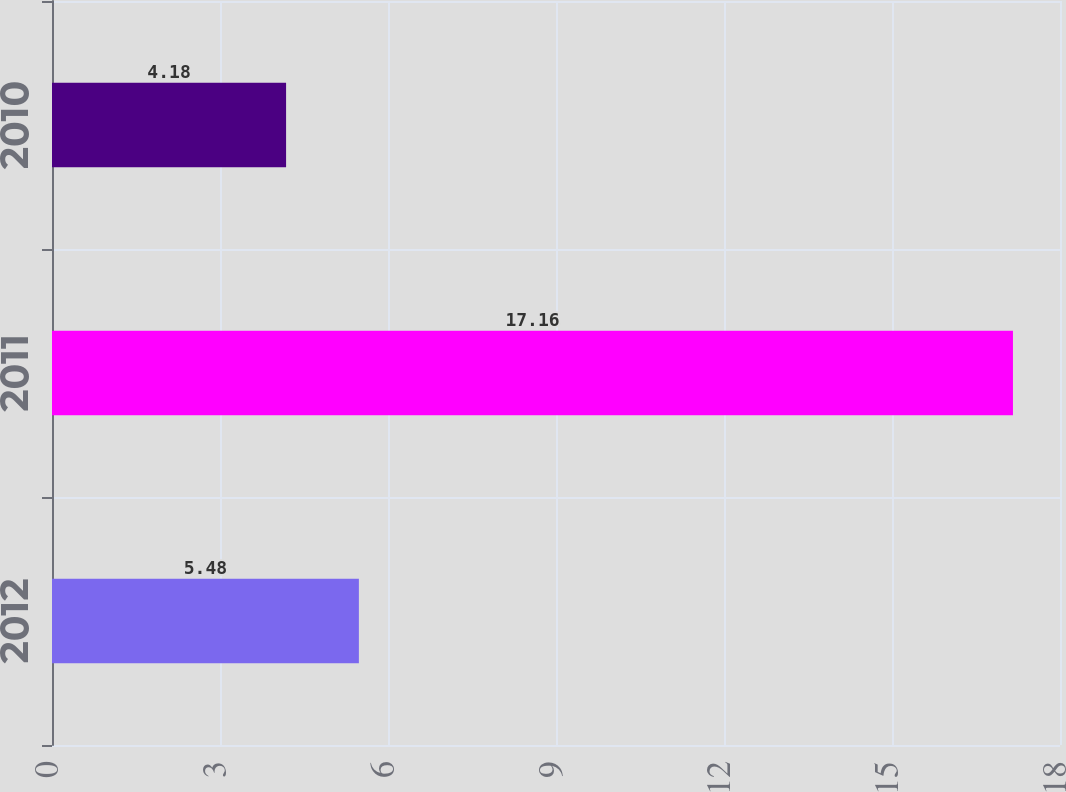Convert chart. <chart><loc_0><loc_0><loc_500><loc_500><bar_chart><fcel>2012<fcel>2011<fcel>2010<nl><fcel>5.48<fcel>17.16<fcel>4.18<nl></chart> 